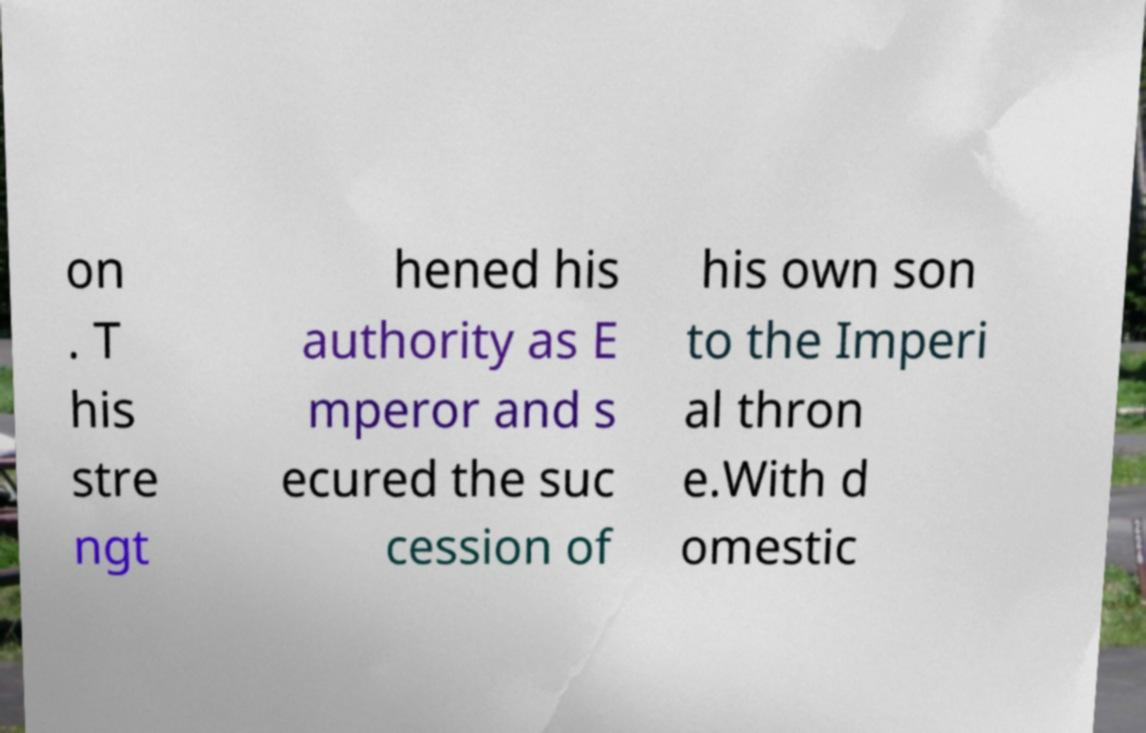Could you assist in decoding the text presented in this image and type it out clearly? on . T his stre ngt hened his authority as E mperor and s ecured the suc cession of his own son to the Imperi al thron e.With d omestic 